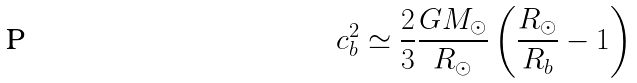Convert formula to latex. <formula><loc_0><loc_0><loc_500><loc_500>c _ { b } ^ { 2 } \simeq \frac { 2 } { 3 } \frac { G M _ { \odot } } { R _ { \odot } } \left ( \frac { R _ { \odot } } { R _ { b } } - 1 \right )</formula> 